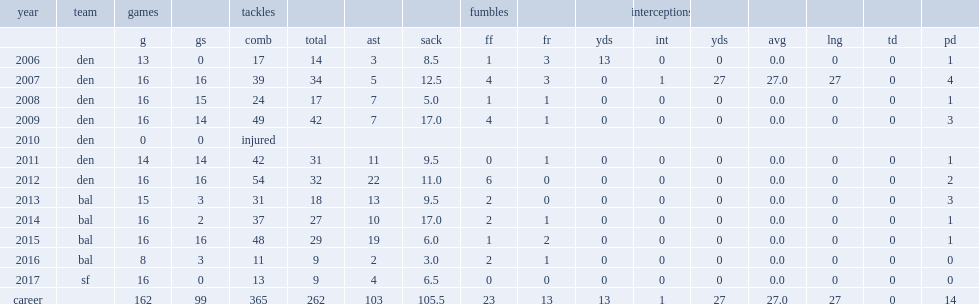How many sacks did dumervil of broncos get in 2007? 12.5. 